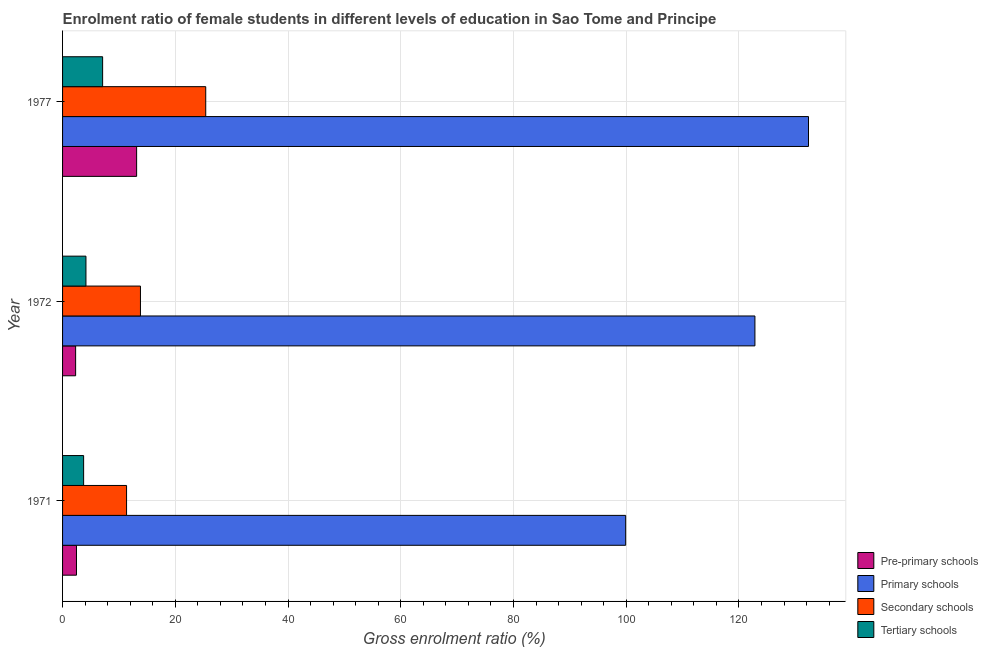How many groups of bars are there?
Your answer should be very brief. 3. Are the number of bars per tick equal to the number of legend labels?
Offer a terse response. Yes. Are the number of bars on each tick of the Y-axis equal?
Offer a very short reply. Yes. How many bars are there on the 1st tick from the top?
Your answer should be compact. 4. In how many cases, is the number of bars for a given year not equal to the number of legend labels?
Make the answer very short. 0. What is the gross enrolment ratio(male) in pre-primary schools in 1971?
Your answer should be very brief. 2.47. Across all years, what is the maximum gross enrolment ratio(male) in pre-primary schools?
Ensure brevity in your answer.  13.14. Across all years, what is the minimum gross enrolment ratio(male) in secondary schools?
Make the answer very short. 11.35. In which year was the gross enrolment ratio(male) in primary schools maximum?
Ensure brevity in your answer.  1977. What is the total gross enrolment ratio(male) in secondary schools in the graph?
Offer a terse response. 50.57. What is the difference between the gross enrolment ratio(male) in primary schools in 1972 and that in 1977?
Your answer should be compact. -9.51. What is the difference between the gross enrolment ratio(male) in secondary schools in 1971 and the gross enrolment ratio(male) in primary schools in 1972?
Give a very brief answer. -111.48. What is the average gross enrolment ratio(male) in primary schools per year?
Your answer should be compact. 118.36. In the year 1972, what is the difference between the gross enrolment ratio(male) in tertiary schools and gross enrolment ratio(male) in secondary schools?
Provide a short and direct response. -9.67. What is the ratio of the gross enrolment ratio(male) in primary schools in 1971 to that in 1977?
Offer a terse response. 0.76. Is the gross enrolment ratio(male) in pre-primary schools in 1972 less than that in 1977?
Ensure brevity in your answer.  Yes. What is the difference between the highest and the second highest gross enrolment ratio(male) in pre-primary schools?
Ensure brevity in your answer.  10.67. What is the difference between the highest and the lowest gross enrolment ratio(male) in tertiary schools?
Make the answer very short. 3.37. What does the 2nd bar from the top in 1972 represents?
Offer a terse response. Secondary schools. What does the 4th bar from the bottom in 1972 represents?
Ensure brevity in your answer.  Tertiary schools. What is the difference between two consecutive major ticks on the X-axis?
Ensure brevity in your answer.  20. Does the graph contain grids?
Your answer should be compact. Yes. Where does the legend appear in the graph?
Make the answer very short. Bottom right. How are the legend labels stacked?
Provide a succinct answer. Vertical. What is the title of the graph?
Ensure brevity in your answer.  Enrolment ratio of female students in different levels of education in Sao Tome and Principe. What is the label or title of the Y-axis?
Offer a terse response. Year. What is the Gross enrolment ratio (%) of Pre-primary schools in 1971?
Your answer should be very brief. 2.47. What is the Gross enrolment ratio (%) of Primary schools in 1971?
Offer a very short reply. 99.9. What is the Gross enrolment ratio (%) in Secondary schools in 1971?
Your answer should be compact. 11.35. What is the Gross enrolment ratio (%) of Tertiary schools in 1971?
Offer a terse response. 3.74. What is the Gross enrolment ratio (%) of Pre-primary schools in 1972?
Make the answer very short. 2.32. What is the Gross enrolment ratio (%) in Primary schools in 1972?
Ensure brevity in your answer.  122.83. What is the Gross enrolment ratio (%) in Secondary schools in 1972?
Your answer should be very brief. 13.82. What is the Gross enrolment ratio (%) in Tertiary schools in 1972?
Your answer should be compact. 4.15. What is the Gross enrolment ratio (%) of Pre-primary schools in 1977?
Offer a very short reply. 13.14. What is the Gross enrolment ratio (%) of Primary schools in 1977?
Your response must be concise. 132.34. What is the Gross enrolment ratio (%) in Secondary schools in 1977?
Make the answer very short. 25.4. What is the Gross enrolment ratio (%) in Tertiary schools in 1977?
Give a very brief answer. 7.11. Across all years, what is the maximum Gross enrolment ratio (%) in Pre-primary schools?
Make the answer very short. 13.14. Across all years, what is the maximum Gross enrolment ratio (%) of Primary schools?
Your answer should be compact. 132.34. Across all years, what is the maximum Gross enrolment ratio (%) in Secondary schools?
Keep it short and to the point. 25.4. Across all years, what is the maximum Gross enrolment ratio (%) of Tertiary schools?
Provide a succinct answer. 7.11. Across all years, what is the minimum Gross enrolment ratio (%) of Pre-primary schools?
Offer a terse response. 2.32. Across all years, what is the minimum Gross enrolment ratio (%) of Primary schools?
Your answer should be very brief. 99.9. Across all years, what is the minimum Gross enrolment ratio (%) in Secondary schools?
Offer a very short reply. 11.35. Across all years, what is the minimum Gross enrolment ratio (%) of Tertiary schools?
Ensure brevity in your answer.  3.74. What is the total Gross enrolment ratio (%) in Pre-primary schools in the graph?
Ensure brevity in your answer.  17.92. What is the total Gross enrolment ratio (%) of Primary schools in the graph?
Keep it short and to the point. 355.07. What is the total Gross enrolment ratio (%) of Secondary schools in the graph?
Offer a very short reply. 50.57. What is the total Gross enrolment ratio (%) of Tertiary schools in the graph?
Provide a succinct answer. 14.99. What is the difference between the Gross enrolment ratio (%) of Pre-primary schools in 1971 and that in 1972?
Offer a very short reply. 0.15. What is the difference between the Gross enrolment ratio (%) of Primary schools in 1971 and that in 1972?
Ensure brevity in your answer.  -22.93. What is the difference between the Gross enrolment ratio (%) of Secondary schools in 1971 and that in 1972?
Provide a succinct answer. -2.47. What is the difference between the Gross enrolment ratio (%) in Tertiary schools in 1971 and that in 1972?
Provide a succinct answer. -0.41. What is the difference between the Gross enrolment ratio (%) in Pre-primary schools in 1971 and that in 1977?
Keep it short and to the point. -10.67. What is the difference between the Gross enrolment ratio (%) in Primary schools in 1971 and that in 1977?
Provide a short and direct response. -32.44. What is the difference between the Gross enrolment ratio (%) in Secondary schools in 1971 and that in 1977?
Ensure brevity in your answer.  -14.04. What is the difference between the Gross enrolment ratio (%) of Tertiary schools in 1971 and that in 1977?
Keep it short and to the point. -3.37. What is the difference between the Gross enrolment ratio (%) in Pre-primary schools in 1972 and that in 1977?
Make the answer very short. -10.82. What is the difference between the Gross enrolment ratio (%) of Primary schools in 1972 and that in 1977?
Give a very brief answer. -9.51. What is the difference between the Gross enrolment ratio (%) of Secondary schools in 1972 and that in 1977?
Keep it short and to the point. -11.58. What is the difference between the Gross enrolment ratio (%) of Tertiary schools in 1972 and that in 1977?
Offer a terse response. -2.96. What is the difference between the Gross enrolment ratio (%) of Pre-primary schools in 1971 and the Gross enrolment ratio (%) of Primary schools in 1972?
Your answer should be compact. -120.36. What is the difference between the Gross enrolment ratio (%) of Pre-primary schools in 1971 and the Gross enrolment ratio (%) of Secondary schools in 1972?
Give a very brief answer. -11.35. What is the difference between the Gross enrolment ratio (%) in Pre-primary schools in 1971 and the Gross enrolment ratio (%) in Tertiary schools in 1972?
Your answer should be very brief. -1.68. What is the difference between the Gross enrolment ratio (%) in Primary schools in 1971 and the Gross enrolment ratio (%) in Secondary schools in 1972?
Keep it short and to the point. 86.08. What is the difference between the Gross enrolment ratio (%) of Primary schools in 1971 and the Gross enrolment ratio (%) of Tertiary schools in 1972?
Give a very brief answer. 95.75. What is the difference between the Gross enrolment ratio (%) in Secondary schools in 1971 and the Gross enrolment ratio (%) in Tertiary schools in 1972?
Offer a terse response. 7.2. What is the difference between the Gross enrolment ratio (%) of Pre-primary schools in 1971 and the Gross enrolment ratio (%) of Primary schools in 1977?
Make the answer very short. -129.87. What is the difference between the Gross enrolment ratio (%) in Pre-primary schools in 1971 and the Gross enrolment ratio (%) in Secondary schools in 1977?
Offer a very short reply. -22.93. What is the difference between the Gross enrolment ratio (%) of Pre-primary schools in 1971 and the Gross enrolment ratio (%) of Tertiary schools in 1977?
Offer a very short reply. -4.64. What is the difference between the Gross enrolment ratio (%) in Primary schools in 1971 and the Gross enrolment ratio (%) in Secondary schools in 1977?
Your answer should be compact. 74.5. What is the difference between the Gross enrolment ratio (%) of Primary schools in 1971 and the Gross enrolment ratio (%) of Tertiary schools in 1977?
Your answer should be very brief. 92.79. What is the difference between the Gross enrolment ratio (%) of Secondary schools in 1971 and the Gross enrolment ratio (%) of Tertiary schools in 1977?
Provide a short and direct response. 4.25. What is the difference between the Gross enrolment ratio (%) of Pre-primary schools in 1972 and the Gross enrolment ratio (%) of Primary schools in 1977?
Provide a succinct answer. -130.02. What is the difference between the Gross enrolment ratio (%) of Pre-primary schools in 1972 and the Gross enrolment ratio (%) of Secondary schools in 1977?
Keep it short and to the point. -23.08. What is the difference between the Gross enrolment ratio (%) of Pre-primary schools in 1972 and the Gross enrolment ratio (%) of Tertiary schools in 1977?
Give a very brief answer. -4.79. What is the difference between the Gross enrolment ratio (%) of Primary schools in 1972 and the Gross enrolment ratio (%) of Secondary schools in 1977?
Give a very brief answer. 97.43. What is the difference between the Gross enrolment ratio (%) in Primary schools in 1972 and the Gross enrolment ratio (%) in Tertiary schools in 1977?
Offer a terse response. 115.72. What is the difference between the Gross enrolment ratio (%) of Secondary schools in 1972 and the Gross enrolment ratio (%) of Tertiary schools in 1977?
Make the answer very short. 6.71. What is the average Gross enrolment ratio (%) of Pre-primary schools per year?
Offer a very short reply. 5.97. What is the average Gross enrolment ratio (%) in Primary schools per year?
Keep it short and to the point. 118.36. What is the average Gross enrolment ratio (%) in Secondary schools per year?
Your answer should be very brief. 16.86. What is the average Gross enrolment ratio (%) of Tertiary schools per year?
Provide a succinct answer. 5. In the year 1971, what is the difference between the Gross enrolment ratio (%) of Pre-primary schools and Gross enrolment ratio (%) of Primary schools?
Your answer should be very brief. -97.43. In the year 1971, what is the difference between the Gross enrolment ratio (%) in Pre-primary schools and Gross enrolment ratio (%) in Secondary schools?
Offer a terse response. -8.88. In the year 1971, what is the difference between the Gross enrolment ratio (%) of Pre-primary schools and Gross enrolment ratio (%) of Tertiary schools?
Make the answer very short. -1.27. In the year 1971, what is the difference between the Gross enrolment ratio (%) of Primary schools and Gross enrolment ratio (%) of Secondary schools?
Offer a very short reply. 88.55. In the year 1971, what is the difference between the Gross enrolment ratio (%) of Primary schools and Gross enrolment ratio (%) of Tertiary schools?
Ensure brevity in your answer.  96.16. In the year 1971, what is the difference between the Gross enrolment ratio (%) of Secondary schools and Gross enrolment ratio (%) of Tertiary schools?
Your response must be concise. 7.62. In the year 1972, what is the difference between the Gross enrolment ratio (%) of Pre-primary schools and Gross enrolment ratio (%) of Primary schools?
Your answer should be compact. -120.51. In the year 1972, what is the difference between the Gross enrolment ratio (%) of Pre-primary schools and Gross enrolment ratio (%) of Secondary schools?
Your answer should be very brief. -11.5. In the year 1972, what is the difference between the Gross enrolment ratio (%) in Pre-primary schools and Gross enrolment ratio (%) in Tertiary schools?
Provide a short and direct response. -1.83. In the year 1972, what is the difference between the Gross enrolment ratio (%) of Primary schools and Gross enrolment ratio (%) of Secondary schools?
Make the answer very short. 109.01. In the year 1972, what is the difference between the Gross enrolment ratio (%) of Primary schools and Gross enrolment ratio (%) of Tertiary schools?
Keep it short and to the point. 118.68. In the year 1972, what is the difference between the Gross enrolment ratio (%) of Secondary schools and Gross enrolment ratio (%) of Tertiary schools?
Make the answer very short. 9.67. In the year 1977, what is the difference between the Gross enrolment ratio (%) in Pre-primary schools and Gross enrolment ratio (%) in Primary schools?
Offer a very short reply. -119.2. In the year 1977, what is the difference between the Gross enrolment ratio (%) of Pre-primary schools and Gross enrolment ratio (%) of Secondary schools?
Provide a succinct answer. -12.26. In the year 1977, what is the difference between the Gross enrolment ratio (%) of Pre-primary schools and Gross enrolment ratio (%) of Tertiary schools?
Ensure brevity in your answer.  6.03. In the year 1977, what is the difference between the Gross enrolment ratio (%) in Primary schools and Gross enrolment ratio (%) in Secondary schools?
Give a very brief answer. 106.94. In the year 1977, what is the difference between the Gross enrolment ratio (%) in Primary schools and Gross enrolment ratio (%) in Tertiary schools?
Ensure brevity in your answer.  125.23. In the year 1977, what is the difference between the Gross enrolment ratio (%) in Secondary schools and Gross enrolment ratio (%) in Tertiary schools?
Your answer should be very brief. 18.29. What is the ratio of the Gross enrolment ratio (%) in Pre-primary schools in 1971 to that in 1972?
Your answer should be very brief. 1.07. What is the ratio of the Gross enrolment ratio (%) in Primary schools in 1971 to that in 1972?
Ensure brevity in your answer.  0.81. What is the ratio of the Gross enrolment ratio (%) in Secondary schools in 1971 to that in 1972?
Give a very brief answer. 0.82. What is the ratio of the Gross enrolment ratio (%) in Tertiary schools in 1971 to that in 1972?
Offer a very short reply. 0.9. What is the ratio of the Gross enrolment ratio (%) of Pre-primary schools in 1971 to that in 1977?
Make the answer very short. 0.19. What is the ratio of the Gross enrolment ratio (%) of Primary schools in 1971 to that in 1977?
Offer a very short reply. 0.75. What is the ratio of the Gross enrolment ratio (%) in Secondary schools in 1971 to that in 1977?
Offer a terse response. 0.45. What is the ratio of the Gross enrolment ratio (%) in Tertiary schools in 1971 to that in 1977?
Give a very brief answer. 0.53. What is the ratio of the Gross enrolment ratio (%) of Pre-primary schools in 1972 to that in 1977?
Offer a terse response. 0.18. What is the ratio of the Gross enrolment ratio (%) in Primary schools in 1972 to that in 1977?
Offer a terse response. 0.93. What is the ratio of the Gross enrolment ratio (%) of Secondary schools in 1972 to that in 1977?
Your answer should be very brief. 0.54. What is the ratio of the Gross enrolment ratio (%) of Tertiary schools in 1972 to that in 1977?
Ensure brevity in your answer.  0.58. What is the difference between the highest and the second highest Gross enrolment ratio (%) in Pre-primary schools?
Your answer should be very brief. 10.67. What is the difference between the highest and the second highest Gross enrolment ratio (%) of Primary schools?
Your response must be concise. 9.51. What is the difference between the highest and the second highest Gross enrolment ratio (%) of Secondary schools?
Your response must be concise. 11.58. What is the difference between the highest and the second highest Gross enrolment ratio (%) of Tertiary schools?
Ensure brevity in your answer.  2.96. What is the difference between the highest and the lowest Gross enrolment ratio (%) of Pre-primary schools?
Provide a short and direct response. 10.82. What is the difference between the highest and the lowest Gross enrolment ratio (%) in Primary schools?
Your response must be concise. 32.44. What is the difference between the highest and the lowest Gross enrolment ratio (%) in Secondary schools?
Offer a terse response. 14.04. What is the difference between the highest and the lowest Gross enrolment ratio (%) in Tertiary schools?
Make the answer very short. 3.37. 